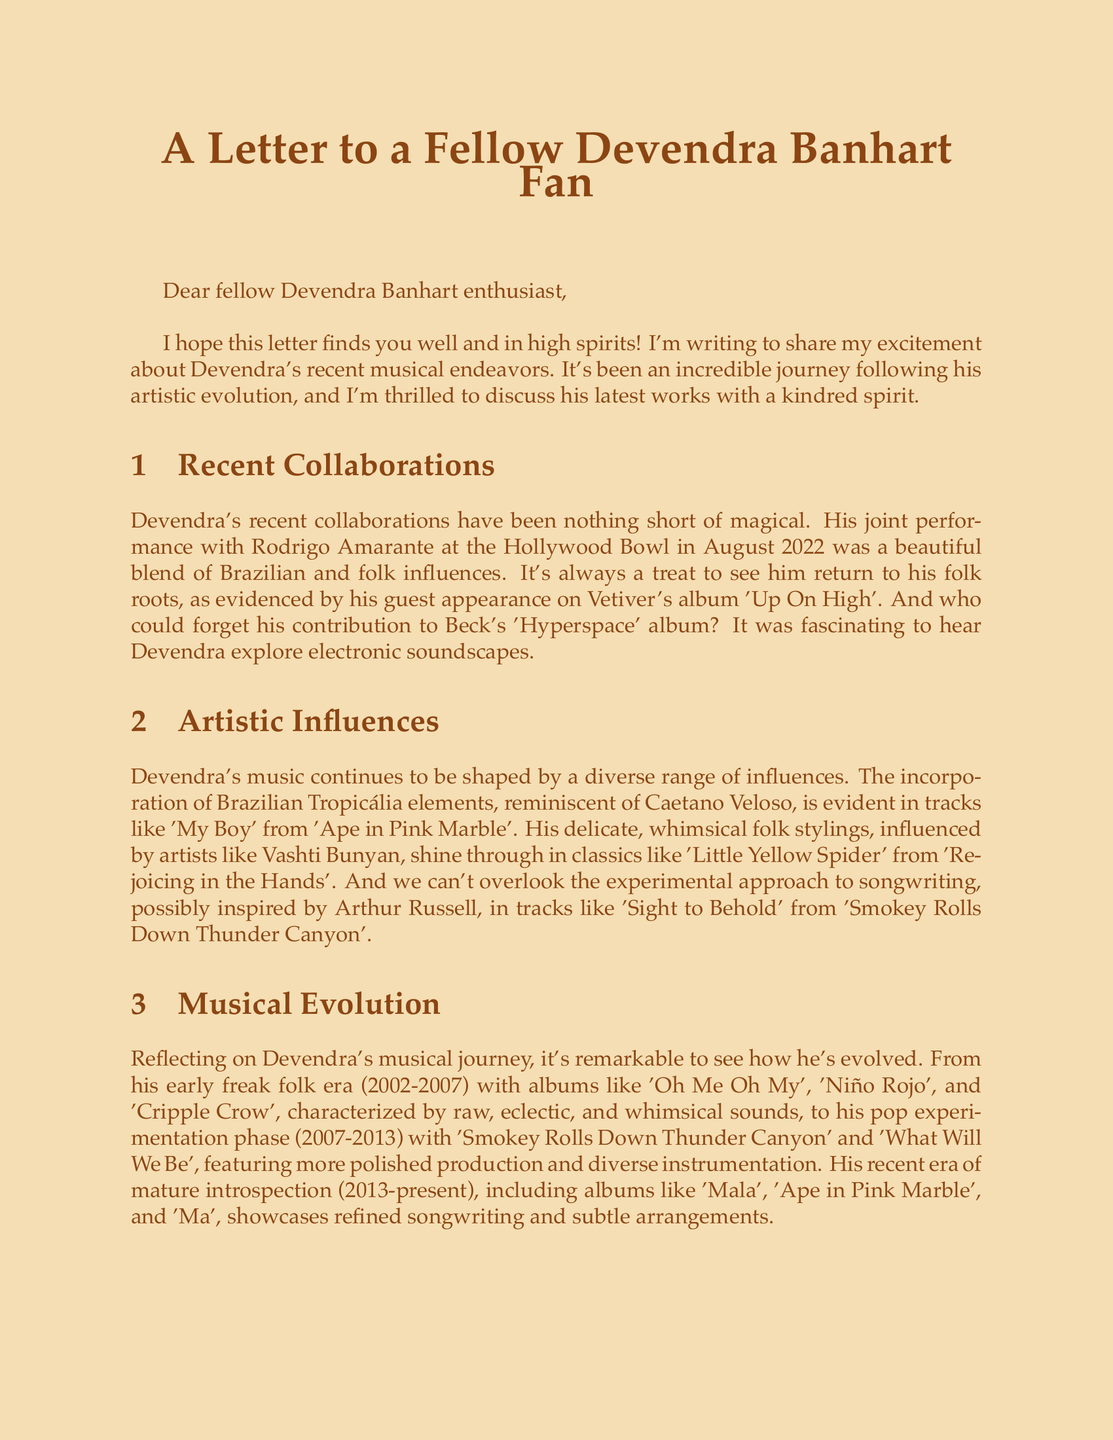What was the joint performance location with Rodrigo Amarante? The document states that the joint performance took place at the Hollywood Bowl in August 2022.
Answer: Hollywood Bowl Who was featured on Vetiver's album 'Up On High'? The letter discusses Devendra's guest appearance on this album, indicating that Vetiver is the artist.
Answer: Vetiver Which artist influenced the incorporation of Brazilian Tropicália elements? The document mentions Caetano Veloso as an influential artist related to Brazilian Tropicália elements.
Answer: Caetano Veloso What describes Devendra's musical era from 2013 to the present? The letter characterizes this era as "Mature introspection" with refined songwriting and subtle arrangements.
Answer: Mature introspection What is speculated about the upcoming new album? The letter speculates that the new album may return to more acoustic arrangements.
Answer: More acoustic arrangements What is the expected release timeframe for the new album? The letter mentions late 2023 as the expected release timeframe for the new album.
Answer: Late 2023 Who is Devendra Banhart collaborating with on an EP? It is noted in the document that Joanna Newsom is the partner for the collaborative EP.
Answer: Joanna Newsom What type of event is scheduled at MOCA Los Angeles? The document describes an art exhibition at this venue showcasing visual art alongside musical performances.
Answer: Art exhibition 